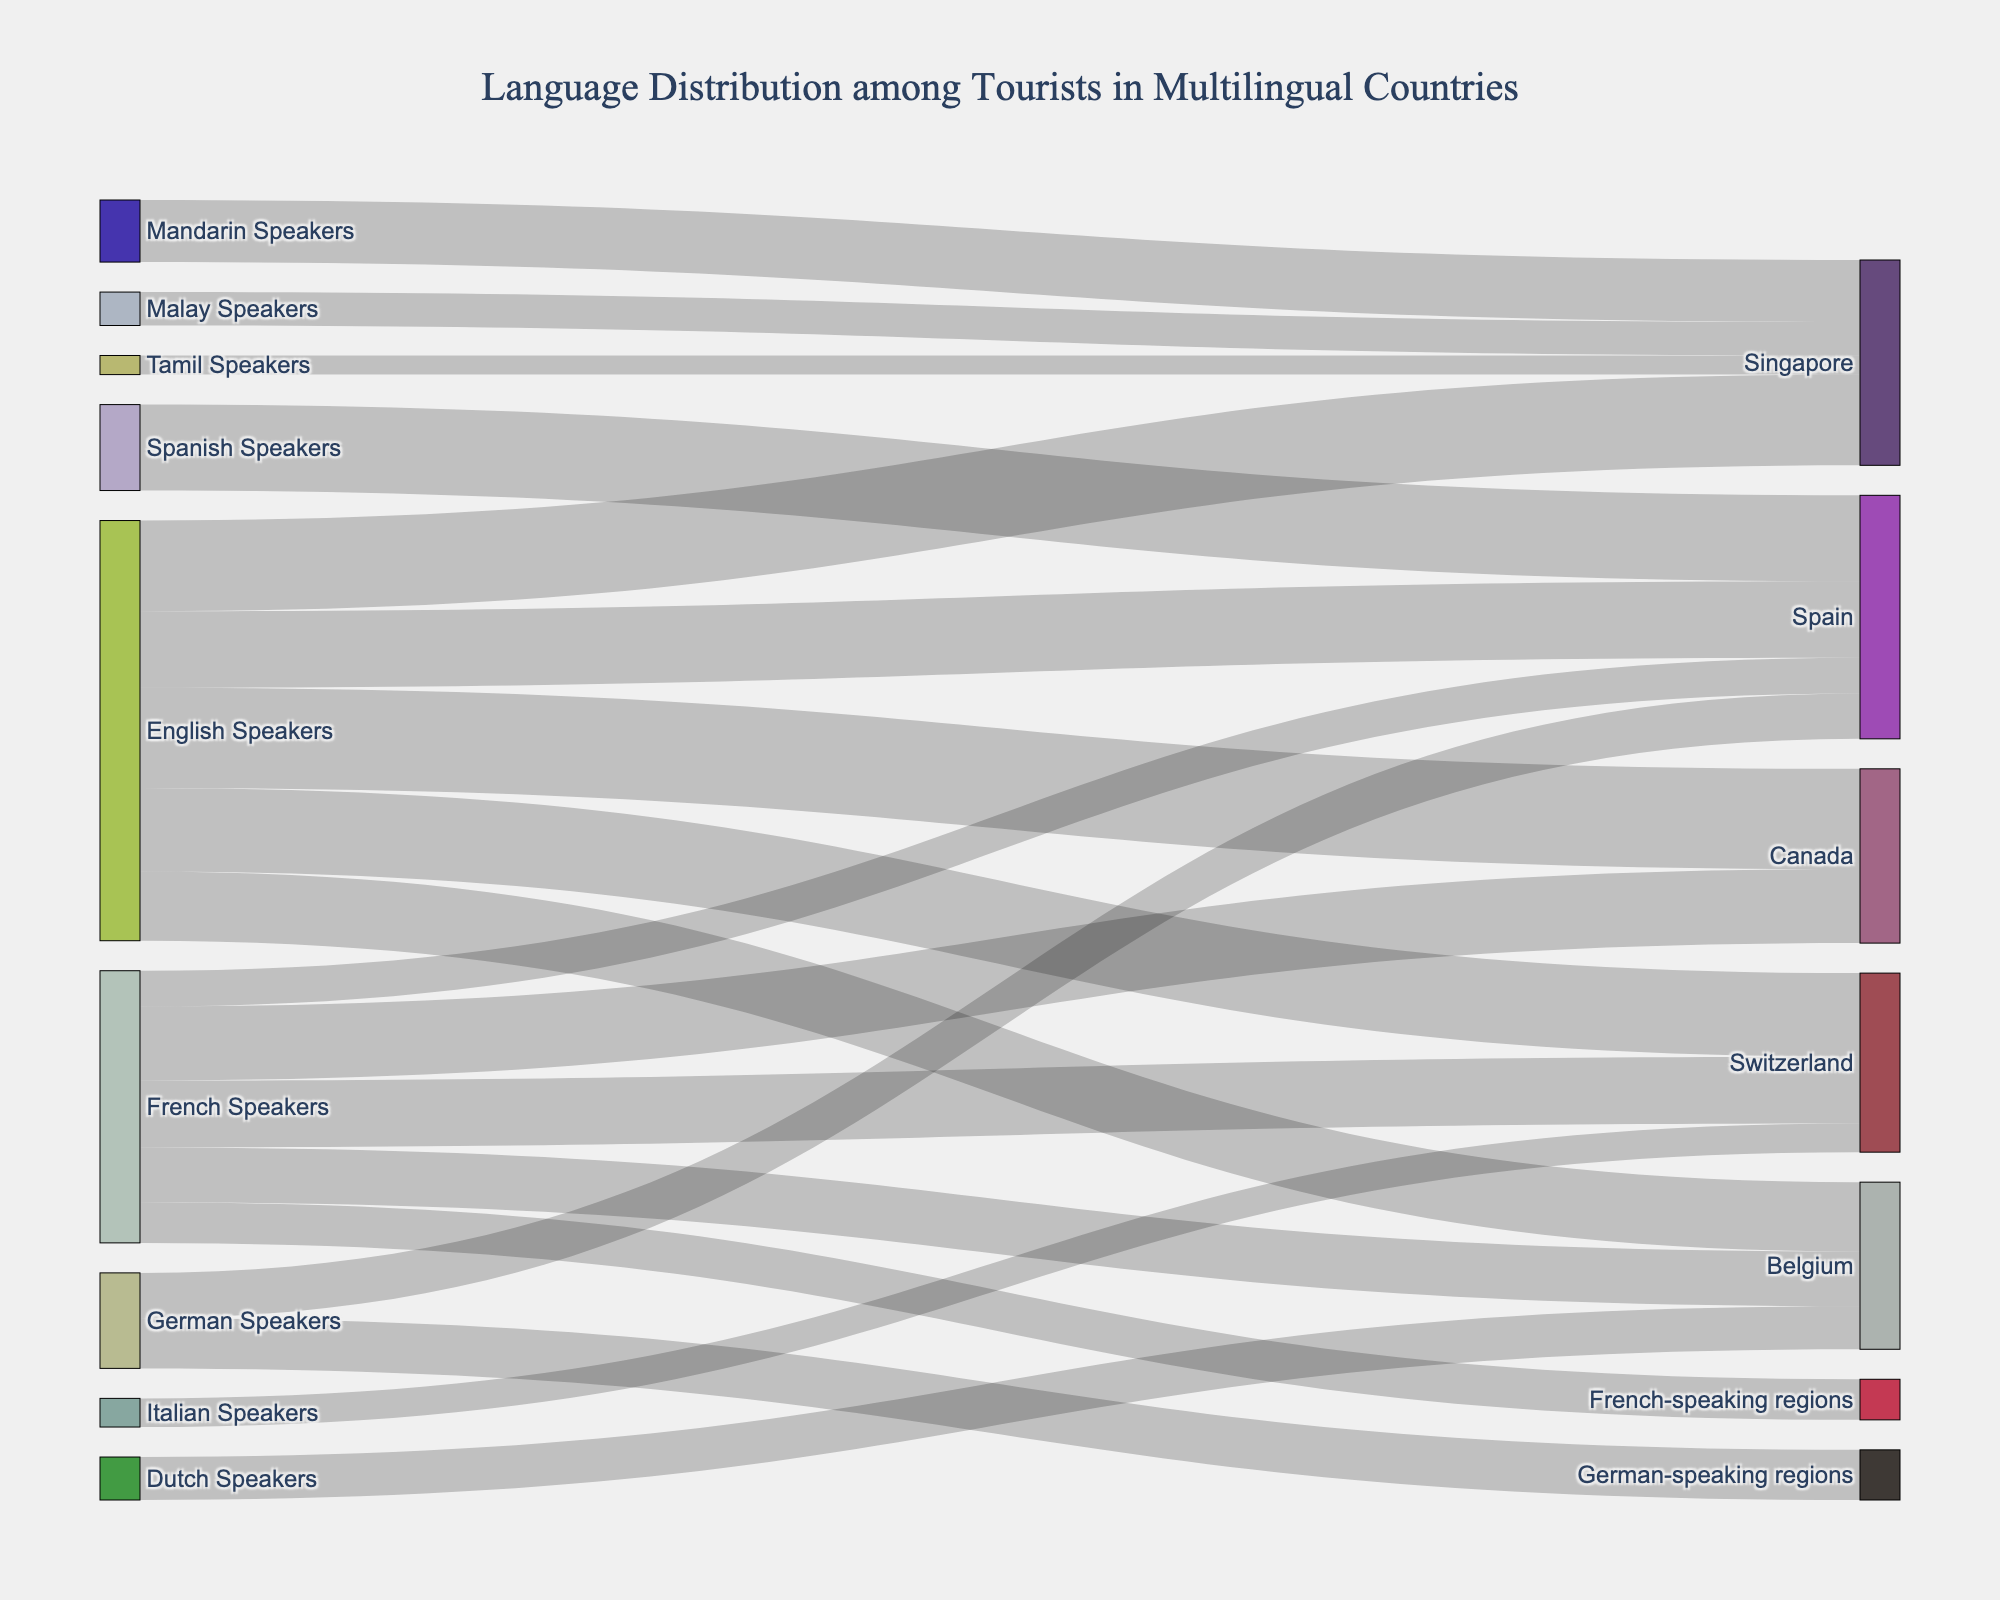What is the title of the figure? The title is usually placed at the top-center of the figure and highlights the main topic of the visual. In this case, the title is "Language Distribution among Tourists in Multilingual Countries."
Answer: Language Distribution among Tourists in Multilingual Countries How many different source languages are depicted in the figure? Identifying the unique sources involves counting the distinct languages listed as sources, which are English, French, German, Italian, Mandarin, Malay, Dutch, and Spanish.
Answer: 8 Which destination receives the highest number of English-speaking tourists? To determine this, we look for the destination connected to "English Speakers" with the highest value. Comparing values for Switzerland (3500), Belgium (2900), Canada (4200), Singapore (3800), and Spain (3200), we see Canada receives the most.
Answer: Canada What are the total tourists visiting Switzerland? Sum the values of all paths leading to Switzerland: 3500 (English) + 2800 (French) + 1200 (Italian) = 7500.
Answer: 7500 Which language group contributes more tourists to Belgium: English Speakers or French Speakers? Comparing the values: English Speakers (2900) vs. French Speakers (2300). English Speakers are more.
Answer: English Speakers How many countries are listed as destinations in the figure? Count the unique destinations which are Switzerland, Belgium, German-speaking regions, French-speaking regions, Canada, Singapore, and Spain. There are 7 destinations in total.
Answer: 7 What is the combined total of tourists speaking Mandarin, Malay, and Tamil visiting Singapore? Sum their values: Mandarin (2600) + Malay (1400) + Tamil (800) = 4800.
Answer: 4800 For the Italian speakers, which country is their destination? The figure shows that Italian Speakers are only directed towards Switzerland with a value of 1200.
Answer: Switzerland Among the languages spoken by tourists visiting Spain, which one has the second highest number of tourists? Arrange the values for Spain's incoming tourists: Spanish (3600), English (3200), German (1900), French (1500). The second highest is English.
Answer: English What proportion of German-speaking tourists visiting Spain compared to those visiting Swiss German-speaking regions? Calculate the ratio: Germany-speaking tourists to Spain (1900) / tourists to German-speaking regions (2100) = 1900/2100 ≈ 0.905.
Answer: ≈ 0.905 